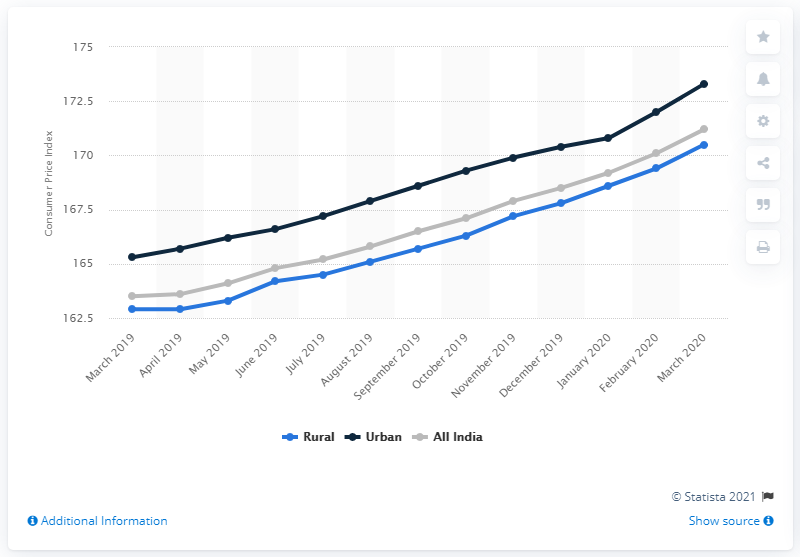Draw attention to some important aspects in this diagram. In March 2020, the Consumer Price Index for tobacco, pan, and intoxicants was 171.2. According to the Consumer Price Index for tobacco, pan, and intoxicants in urban India in March of 2020, the value was 173.3. 